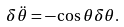Convert formula to latex. <formula><loc_0><loc_0><loc_500><loc_500>\delta \ddot { \theta } = - \cos \theta \delta \theta .</formula> 